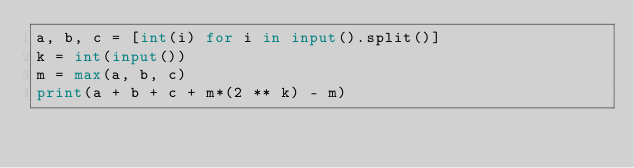<code> <loc_0><loc_0><loc_500><loc_500><_Python_>a, b, c = [int(i) for i in input().split()]
k = int(input())
m = max(a, b, c)
print(a + b + c + m*(2 ** k) - m)
</code> 